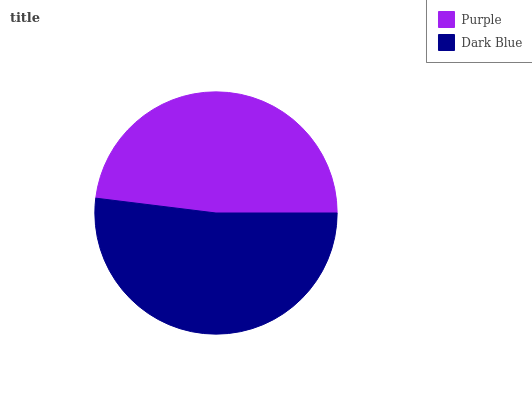Is Purple the minimum?
Answer yes or no. Yes. Is Dark Blue the maximum?
Answer yes or no. Yes. Is Dark Blue the minimum?
Answer yes or no. No. Is Dark Blue greater than Purple?
Answer yes or no. Yes. Is Purple less than Dark Blue?
Answer yes or no. Yes. Is Purple greater than Dark Blue?
Answer yes or no. No. Is Dark Blue less than Purple?
Answer yes or no. No. Is Dark Blue the high median?
Answer yes or no. Yes. Is Purple the low median?
Answer yes or no. Yes. Is Purple the high median?
Answer yes or no. No. Is Dark Blue the low median?
Answer yes or no. No. 